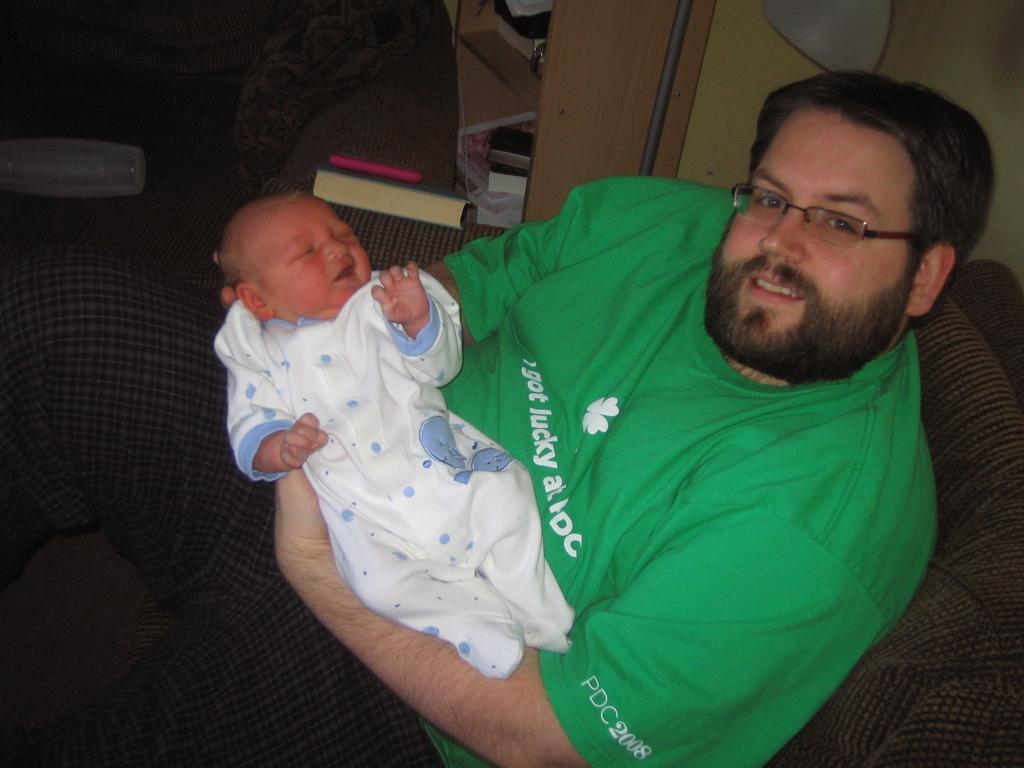What year is listed on the sleeve?
Provide a short and direct response. 2008. What did he get at pdc?
Make the answer very short. Lucky. 